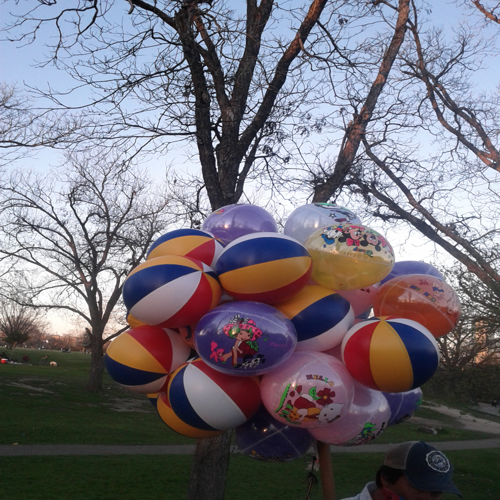What might be the occasion for these balloons? The mixture of lively colors and the way they are bunched together suggest these balloons could be part of a festive occasion, such as a party in the park, a birthday celebration, or possibly an outdoor event or festival where balloons are commonly used as decorations. 